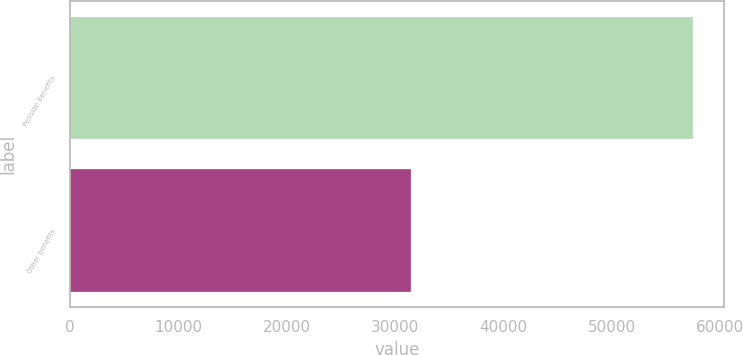Convert chart to OTSL. <chart><loc_0><loc_0><loc_500><loc_500><bar_chart><fcel>Pension benefits<fcel>Other benefits<nl><fcel>57512<fcel>31500<nl></chart> 